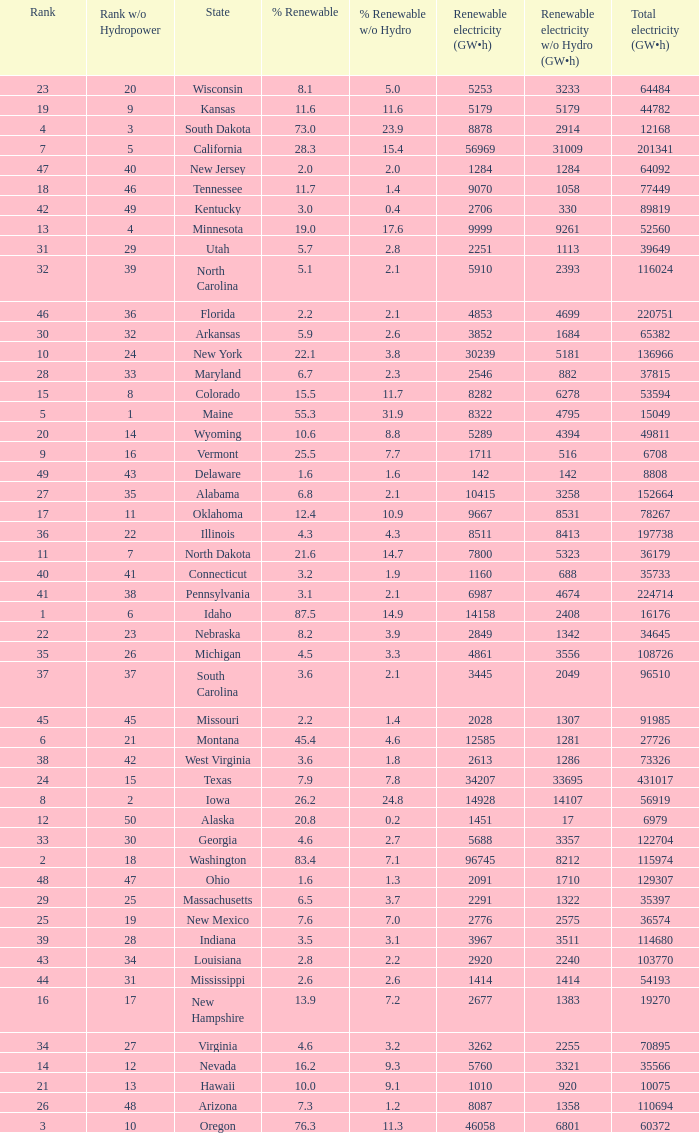Which state has 5179 (gw×h) of renewable energy without hydrogen power?wha Kansas. 